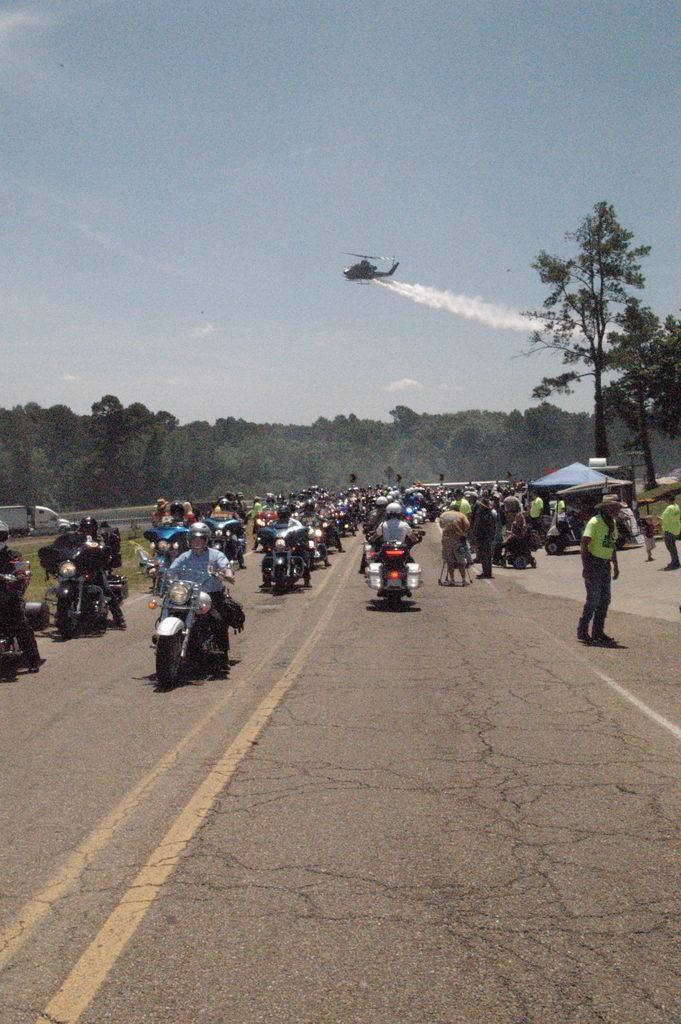Describe this image in one or two sentences. In this image there are vehicles ,trees and people in the right corner. There are people on vehicles in the foreground. There are trees in the background. There is a helicopter. There is a road at the bottom. And there is a sky at the top. 